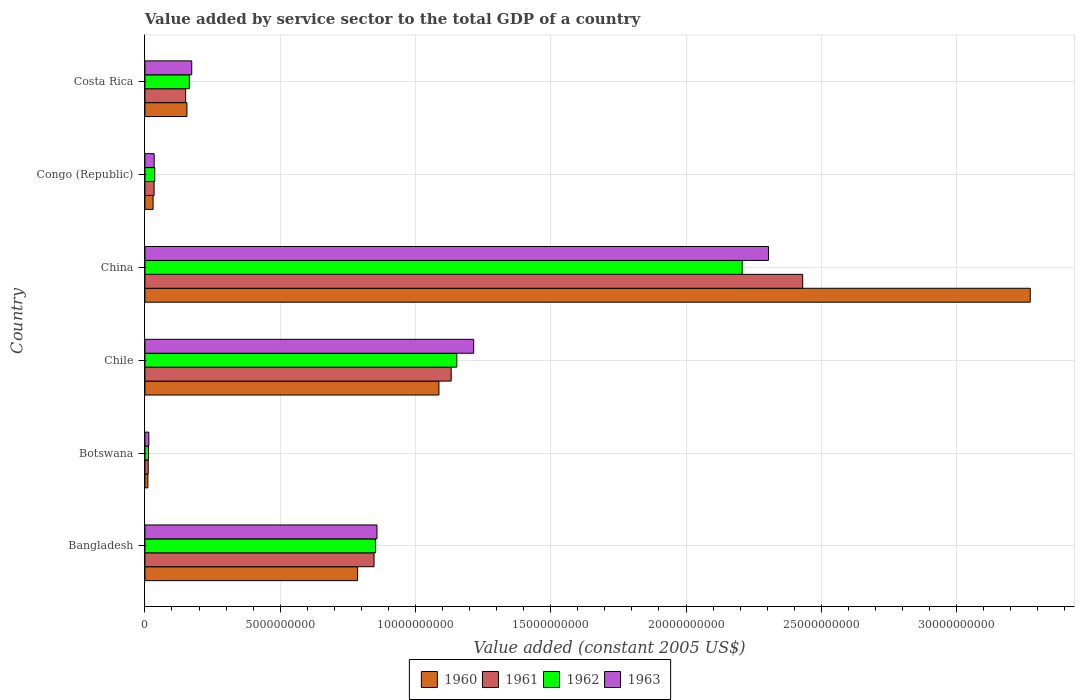How many groups of bars are there?
Provide a succinct answer. 6. Are the number of bars per tick equal to the number of legend labels?
Your response must be concise. Yes. Are the number of bars on each tick of the Y-axis equal?
Ensure brevity in your answer.  Yes. How many bars are there on the 3rd tick from the top?
Your answer should be compact. 4. What is the label of the 4th group of bars from the top?
Your answer should be compact. Chile. What is the value added by service sector in 1962 in Costa Rica?
Offer a very short reply. 1.64e+09. Across all countries, what is the maximum value added by service sector in 1960?
Keep it short and to the point. 3.27e+1. Across all countries, what is the minimum value added by service sector in 1961?
Offer a very short reply. 1.22e+08. In which country was the value added by service sector in 1960 maximum?
Your answer should be very brief. China. In which country was the value added by service sector in 1963 minimum?
Provide a short and direct response. Botswana. What is the total value added by service sector in 1960 in the graph?
Keep it short and to the point. 5.34e+1. What is the difference between the value added by service sector in 1962 in Bangladesh and that in Botswana?
Ensure brevity in your answer.  8.39e+09. What is the difference between the value added by service sector in 1962 in Botswana and the value added by service sector in 1963 in Bangladesh?
Keep it short and to the point. -8.44e+09. What is the average value added by service sector in 1960 per country?
Offer a terse response. 8.90e+09. What is the difference between the value added by service sector in 1962 and value added by service sector in 1961 in China?
Ensure brevity in your answer.  -2.24e+09. What is the ratio of the value added by service sector in 1963 in Congo (Republic) to that in Costa Rica?
Offer a terse response. 0.2. Is the difference between the value added by service sector in 1962 in Bangladesh and Costa Rica greater than the difference between the value added by service sector in 1961 in Bangladesh and Costa Rica?
Keep it short and to the point. No. What is the difference between the highest and the second highest value added by service sector in 1962?
Provide a short and direct response. 1.05e+1. What is the difference between the highest and the lowest value added by service sector in 1960?
Your answer should be compact. 3.26e+1. In how many countries, is the value added by service sector in 1960 greater than the average value added by service sector in 1960 taken over all countries?
Provide a short and direct response. 2. Is the sum of the value added by service sector in 1963 in Bangladesh and Chile greater than the maximum value added by service sector in 1960 across all countries?
Your answer should be compact. No. Is it the case that in every country, the sum of the value added by service sector in 1961 and value added by service sector in 1962 is greater than the sum of value added by service sector in 1963 and value added by service sector in 1960?
Your answer should be very brief. No. What does the 3rd bar from the bottom in Congo (Republic) represents?
Offer a terse response. 1962. How many bars are there?
Make the answer very short. 24. How many countries are there in the graph?
Your answer should be very brief. 6. Does the graph contain any zero values?
Your response must be concise. No. Does the graph contain grids?
Ensure brevity in your answer.  Yes. How many legend labels are there?
Your answer should be very brief. 4. How are the legend labels stacked?
Offer a very short reply. Horizontal. What is the title of the graph?
Offer a terse response. Value added by service sector to the total GDP of a country. What is the label or title of the X-axis?
Offer a very short reply. Value added (constant 2005 US$). What is the label or title of the Y-axis?
Keep it short and to the point. Country. What is the Value added (constant 2005 US$) in 1960 in Bangladesh?
Your response must be concise. 7.86e+09. What is the Value added (constant 2005 US$) in 1961 in Bangladesh?
Your answer should be compact. 8.47e+09. What is the Value added (constant 2005 US$) of 1962 in Bangladesh?
Keep it short and to the point. 8.52e+09. What is the Value added (constant 2005 US$) in 1963 in Bangladesh?
Keep it short and to the point. 8.58e+09. What is the Value added (constant 2005 US$) in 1960 in Botswana?
Your answer should be very brief. 1.11e+08. What is the Value added (constant 2005 US$) in 1961 in Botswana?
Offer a terse response. 1.22e+08. What is the Value added (constant 2005 US$) in 1962 in Botswana?
Your answer should be very brief. 1.32e+08. What is the Value added (constant 2005 US$) of 1963 in Botswana?
Your answer should be very brief. 1.45e+08. What is the Value added (constant 2005 US$) of 1960 in Chile?
Give a very brief answer. 1.09e+1. What is the Value added (constant 2005 US$) of 1961 in Chile?
Your response must be concise. 1.13e+1. What is the Value added (constant 2005 US$) of 1962 in Chile?
Give a very brief answer. 1.15e+1. What is the Value added (constant 2005 US$) of 1963 in Chile?
Your answer should be very brief. 1.22e+1. What is the Value added (constant 2005 US$) of 1960 in China?
Keep it short and to the point. 3.27e+1. What is the Value added (constant 2005 US$) in 1961 in China?
Your answer should be compact. 2.43e+1. What is the Value added (constant 2005 US$) of 1962 in China?
Make the answer very short. 2.21e+1. What is the Value added (constant 2005 US$) of 1963 in China?
Make the answer very short. 2.30e+1. What is the Value added (constant 2005 US$) in 1960 in Congo (Republic)?
Your answer should be compact. 3.02e+08. What is the Value added (constant 2005 US$) of 1961 in Congo (Republic)?
Your answer should be compact. 3.39e+08. What is the Value added (constant 2005 US$) of 1962 in Congo (Republic)?
Provide a short and direct response. 3.64e+08. What is the Value added (constant 2005 US$) in 1963 in Congo (Republic)?
Your response must be concise. 3.42e+08. What is the Value added (constant 2005 US$) in 1960 in Costa Rica?
Your response must be concise. 1.55e+09. What is the Value added (constant 2005 US$) in 1961 in Costa Rica?
Offer a very short reply. 1.51e+09. What is the Value added (constant 2005 US$) in 1962 in Costa Rica?
Offer a terse response. 1.64e+09. What is the Value added (constant 2005 US$) in 1963 in Costa Rica?
Offer a terse response. 1.73e+09. Across all countries, what is the maximum Value added (constant 2005 US$) of 1960?
Ensure brevity in your answer.  3.27e+1. Across all countries, what is the maximum Value added (constant 2005 US$) in 1961?
Your response must be concise. 2.43e+1. Across all countries, what is the maximum Value added (constant 2005 US$) in 1962?
Keep it short and to the point. 2.21e+1. Across all countries, what is the maximum Value added (constant 2005 US$) in 1963?
Give a very brief answer. 2.30e+1. Across all countries, what is the minimum Value added (constant 2005 US$) of 1960?
Your answer should be compact. 1.11e+08. Across all countries, what is the minimum Value added (constant 2005 US$) in 1961?
Keep it short and to the point. 1.22e+08. Across all countries, what is the minimum Value added (constant 2005 US$) of 1962?
Provide a short and direct response. 1.32e+08. Across all countries, what is the minimum Value added (constant 2005 US$) of 1963?
Ensure brevity in your answer.  1.45e+08. What is the total Value added (constant 2005 US$) in 1960 in the graph?
Keep it short and to the point. 5.34e+1. What is the total Value added (constant 2005 US$) of 1961 in the graph?
Give a very brief answer. 4.61e+1. What is the total Value added (constant 2005 US$) of 1962 in the graph?
Give a very brief answer. 4.43e+1. What is the total Value added (constant 2005 US$) of 1963 in the graph?
Provide a short and direct response. 4.60e+1. What is the difference between the Value added (constant 2005 US$) of 1960 in Bangladesh and that in Botswana?
Keep it short and to the point. 7.75e+09. What is the difference between the Value added (constant 2005 US$) of 1961 in Bangladesh and that in Botswana?
Your answer should be very brief. 8.35e+09. What is the difference between the Value added (constant 2005 US$) of 1962 in Bangladesh and that in Botswana?
Provide a short and direct response. 8.39e+09. What is the difference between the Value added (constant 2005 US$) in 1963 in Bangladesh and that in Botswana?
Ensure brevity in your answer.  8.43e+09. What is the difference between the Value added (constant 2005 US$) of 1960 in Bangladesh and that in Chile?
Your answer should be very brief. -3.01e+09. What is the difference between the Value added (constant 2005 US$) in 1961 in Bangladesh and that in Chile?
Your answer should be very brief. -2.85e+09. What is the difference between the Value added (constant 2005 US$) in 1962 in Bangladesh and that in Chile?
Give a very brief answer. -3.00e+09. What is the difference between the Value added (constant 2005 US$) of 1963 in Bangladesh and that in Chile?
Ensure brevity in your answer.  -3.58e+09. What is the difference between the Value added (constant 2005 US$) of 1960 in Bangladesh and that in China?
Keep it short and to the point. -2.49e+1. What is the difference between the Value added (constant 2005 US$) in 1961 in Bangladesh and that in China?
Your answer should be compact. -1.58e+1. What is the difference between the Value added (constant 2005 US$) in 1962 in Bangladesh and that in China?
Your response must be concise. -1.36e+1. What is the difference between the Value added (constant 2005 US$) of 1963 in Bangladesh and that in China?
Offer a terse response. -1.45e+1. What is the difference between the Value added (constant 2005 US$) of 1960 in Bangladesh and that in Congo (Republic)?
Make the answer very short. 7.56e+09. What is the difference between the Value added (constant 2005 US$) of 1961 in Bangladesh and that in Congo (Republic)?
Keep it short and to the point. 8.13e+09. What is the difference between the Value added (constant 2005 US$) in 1962 in Bangladesh and that in Congo (Republic)?
Give a very brief answer. 8.16e+09. What is the difference between the Value added (constant 2005 US$) in 1963 in Bangladesh and that in Congo (Republic)?
Provide a succinct answer. 8.24e+09. What is the difference between the Value added (constant 2005 US$) of 1960 in Bangladesh and that in Costa Rica?
Offer a very short reply. 6.31e+09. What is the difference between the Value added (constant 2005 US$) in 1961 in Bangladesh and that in Costa Rica?
Your answer should be compact. 6.96e+09. What is the difference between the Value added (constant 2005 US$) in 1962 in Bangladesh and that in Costa Rica?
Your response must be concise. 6.88e+09. What is the difference between the Value added (constant 2005 US$) in 1963 in Bangladesh and that in Costa Rica?
Ensure brevity in your answer.  6.85e+09. What is the difference between the Value added (constant 2005 US$) in 1960 in Botswana and that in Chile?
Provide a succinct answer. -1.08e+1. What is the difference between the Value added (constant 2005 US$) of 1961 in Botswana and that in Chile?
Offer a very short reply. -1.12e+1. What is the difference between the Value added (constant 2005 US$) of 1962 in Botswana and that in Chile?
Keep it short and to the point. -1.14e+1. What is the difference between the Value added (constant 2005 US$) in 1963 in Botswana and that in Chile?
Provide a succinct answer. -1.20e+1. What is the difference between the Value added (constant 2005 US$) of 1960 in Botswana and that in China?
Provide a short and direct response. -3.26e+1. What is the difference between the Value added (constant 2005 US$) in 1961 in Botswana and that in China?
Your answer should be very brief. -2.42e+1. What is the difference between the Value added (constant 2005 US$) of 1962 in Botswana and that in China?
Your response must be concise. -2.19e+1. What is the difference between the Value added (constant 2005 US$) in 1963 in Botswana and that in China?
Ensure brevity in your answer.  -2.29e+1. What is the difference between the Value added (constant 2005 US$) of 1960 in Botswana and that in Congo (Republic)?
Your answer should be compact. -1.91e+08. What is the difference between the Value added (constant 2005 US$) in 1961 in Botswana and that in Congo (Republic)?
Provide a short and direct response. -2.17e+08. What is the difference between the Value added (constant 2005 US$) in 1962 in Botswana and that in Congo (Republic)?
Your answer should be very brief. -2.32e+08. What is the difference between the Value added (constant 2005 US$) in 1963 in Botswana and that in Congo (Republic)?
Ensure brevity in your answer.  -1.97e+08. What is the difference between the Value added (constant 2005 US$) of 1960 in Botswana and that in Costa Rica?
Offer a very short reply. -1.44e+09. What is the difference between the Value added (constant 2005 US$) in 1961 in Botswana and that in Costa Rica?
Give a very brief answer. -1.38e+09. What is the difference between the Value added (constant 2005 US$) of 1962 in Botswana and that in Costa Rica?
Your response must be concise. -1.51e+09. What is the difference between the Value added (constant 2005 US$) of 1963 in Botswana and that in Costa Rica?
Offer a terse response. -1.59e+09. What is the difference between the Value added (constant 2005 US$) of 1960 in Chile and that in China?
Your answer should be very brief. -2.19e+1. What is the difference between the Value added (constant 2005 US$) in 1961 in Chile and that in China?
Provide a succinct answer. -1.30e+1. What is the difference between the Value added (constant 2005 US$) in 1962 in Chile and that in China?
Your answer should be very brief. -1.05e+1. What is the difference between the Value added (constant 2005 US$) in 1963 in Chile and that in China?
Give a very brief answer. -1.09e+1. What is the difference between the Value added (constant 2005 US$) in 1960 in Chile and that in Congo (Republic)?
Your answer should be compact. 1.06e+1. What is the difference between the Value added (constant 2005 US$) in 1961 in Chile and that in Congo (Republic)?
Your answer should be very brief. 1.10e+1. What is the difference between the Value added (constant 2005 US$) of 1962 in Chile and that in Congo (Republic)?
Make the answer very short. 1.12e+1. What is the difference between the Value added (constant 2005 US$) in 1963 in Chile and that in Congo (Republic)?
Provide a succinct answer. 1.18e+1. What is the difference between the Value added (constant 2005 US$) in 1960 in Chile and that in Costa Rica?
Offer a very short reply. 9.31e+09. What is the difference between the Value added (constant 2005 US$) of 1961 in Chile and that in Costa Rica?
Your answer should be compact. 9.81e+09. What is the difference between the Value added (constant 2005 US$) of 1962 in Chile and that in Costa Rica?
Keep it short and to the point. 9.89e+09. What is the difference between the Value added (constant 2005 US$) of 1963 in Chile and that in Costa Rica?
Provide a short and direct response. 1.04e+1. What is the difference between the Value added (constant 2005 US$) of 1960 in China and that in Congo (Republic)?
Make the answer very short. 3.24e+1. What is the difference between the Value added (constant 2005 US$) of 1961 in China and that in Congo (Republic)?
Your answer should be compact. 2.40e+1. What is the difference between the Value added (constant 2005 US$) in 1962 in China and that in Congo (Republic)?
Give a very brief answer. 2.17e+1. What is the difference between the Value added (constant 2005 US$) in 1963 in China and that in Congo (Republic)?
Offer a terse response. 2.27e+1. What is the difference between the Value added (constant 2005 US$) of 1960 in China and that in Costa Rica?
Make the answer very short. 3.12e+1. What is the difference between the Value added (constant 2005 US$) in 1961 in China and that in Costa Rica?
Your answer should be compact. 2.28e+1. What is the difference between the Value added (constant 2005 US$) in 1962 in China and that in Costa Rica?
Provide a short and direct response. 2.04e+1. What is the difference between the Value added (constant 2005 US$) of 1963 in China and that in Costa Rica?
Offer a terse response. 2.13e+1. What is the difference between the Value added (constant 2005 US$) in 1960 in Congo (Republic) and that in Costa Rica?
Provide a short and direct response. -1.25e+09. What is the difference between the Value added (constant 2005 US$) of 1961 in Congo (Republic) and that in Costa Rica?
Your answer should be very brief. -1.17e+09. What is the difference between the Value added (constant 2005 US$) in 1962 in Congo (Republic) and that in Costa Rica?
Ensure brevity in your answer.  -1.28e+09. What is the difference between the Value added (constant 2005 US$) in 1963 in Congo (Republic) and that in Costa Rica?
Ensure brevity in your answer.  -1.39e+09. What is the difference between the Value added (constant 2005 US$) of 1960 in Bangladesh and the Value added (constant 2005 US$) of 1961 in Botswana?
Make the answer very short. 7.74e+09. What is the difference between the Value added (constant 2005 US$) of 1960 in Bangladesh and the Value added (constant 2005 US$) of 1962 in Botswana?
Your response must be concise. 7.73e+09. What is the difference between the Value added (constant 2005 US$) in 1960 in Bangladesh and the Value added (constant 2005 US$) in 1963 in Botswana?
Keep it short and to the point. 7.72e+09. What is the difference between the Value added (constant 2005 US$) of 1961 in Bangladesh and the Value added (constant 2005 US$) of 1962 in Botswana?
Give a very brief answer. 8.34e+09. What is the difference between the Value added (constant 2005 US$) in 1961 in Bangladesh and the Value added (constant 2005 US$) in 1963 in Botswana?
Your response must be concise. 8.32e+09. What is the difference between the Value added (constant 2005 US$) in 1962 in Bangladesh and the Value added (constant 2005 US$) in 1963 in Botswana?
Offer a terse response. 8.38e+09. What is the difference between the Value added (constant 2005 US$) in 1960 in Bangladesh and the Value added (constant 2005 US$) in 1961 in Chile?
Your answer should be very brief. -3.46e+09. What is the difference between the Value added (constant 2005 US$) in 1960 in Bangladesh and the Value added (constant 2005 US$) in 1962 in Chile?
Provide a succinct answer. -3.67e+09. What is the difference between the Value added (constant 2005 US$) in 1960 in Bangladesh and the Value added (constant 2005 US$) in 1963 in Chile?
Provide a succinct answer. -4.29e+09. What is the difference between the Value added (constant 2005 US$) of 1961 in Bangladesh and the Value added (constant 2005 US$) of 1962 in Chile?
Offer a very short reply. -3.06e+09. What is the difference between the Value added (constant 2005 US$) in 1961 in Bangladesh and the Value added (constant 2005 US$) in 1963 in Chile?
Your answer should be compact. -3.68e+09. What is the difference between the Value added (constant 2005 US$) of 1962 in Bangladesh and the Value added (constant 2005 US$) of 1963 in Chile?
Provide a short and direct response. -3.63e+09. What is the difference between the Value added (constant 2005 US$) of 1960 in Bangladesh and the Value added (constant 2005 US$) of 1961 in China?
Your answer should be compact. -1.65e+1. What is the difference between the Value added (constant 2005 US$) in 1960 in Bangladesh and the Value added (constant 2005 US$) in 1962 in China?
Your answer should be very brief. -1.42e+1. What is the difference between the Value added (constant 2005 US$) of 1960 in Bangladesh and the Value added (constant 2005 US$) of 1963 in China?
Make the answer very short. -1.52e+1. What is the difference between the Value added (constant 2005 US$) in 1961 in Bangladesh and the Value added (constant 2005 US$) in 1962 in China?
Keep it short and to the point. -1.36e+1. What is the difference between the Value added (constant 2005 US$) of 1961 in Bangladesh and the Value added (constant 2005 US$) of 1963 in China?
Your response must be concise. -1.46e+1. What is the difference between the Value added (constant 2005 US$) of 1962 in Bangladesh and the Value added (constant 2005 US$) of 1963 in China?
Offer a terse response. -1.45e+1. What is the difference between the Value added (constant 2005 US$) in 1960 in Bangladesh and the Value added (constant 2005 US$) in 1961 in Congo (Republic)?
Keep it short and to the point. 7.52e+09. What is the difference between the Value added (constant 2005 US$) of 1960 in Bangladesh and the Value added (constant 2005 US$) of 1962 in Congo (Republic)?
Keep it short and to the point. 7.50e+09. What is the difference between the Value added (constant 2005 US$) in 1960 in Bangladesh and the Value added (constant 2005 US$) in 1963 in Congo (Republic)?
Provide a short and direct response. 7.52e+09. What is the difference between the Value added (constant 2005 US$) in 1961 in Bangladesh and the Value added (constant 2005 US$) in 1962 in Congo (Republic)?
Offer a very short reply. 8.11e+09. What is the difference between the Value added (constant 2005 US$) of 1961 in Bangladesh and the Value added (constant 2005 US$) of 1963 in Congo (Republic)?
Give a very brief answer. 8.13e+09. What is the difference between the Value added (constant 2005 US$) in 1962 in Bangladesh and the Value added (constant 2005 US$) in 1963 in Congo (Republic)?
Offer a terse response. 8.18e+09. What is the difference between the Value added (constant 2005 US$) in 1960 in Bangladesh and the Value added (constant 2005 US$) in 1961 in Costa Rica?
Provide a succinct answer. 6.36e+09. What is the difference between the Value added (constant 2005 US$) of 1960 in Bangladesh and the Value added (constant 2005 US$) of 1962 in Costa Rica?
Your response must be concise. 6.22e+09. What is the difference between the Value added (constant 2005 US$) of 1960 in Bangladesh and the Value added (constant 2005 US$) of 1963 in Costa Rica?
Give a very brief answer. 6.13e+09. What is the difference between the Value added (constant 2005 US$) in 1961 in Bangladesh and the Value added (constant 2005 US$) in 1962 in Costa Rica?
Keep it short and to the point. 6.83e+09. What is the difference between the Value added (constant 2005 US$) in 1961 in Bangladesh and the Value added (constant 2005 US$) in 1963 in Costa Rica?
Make the answer very short. 6.74e+09. What is the difference between the Value added (constant 2005 US$) of 1962 in Bangladesh and the Value added (constant 2005 US$) of 1963 in Costa Rica?
Provide a succinct answer. 6.79e+09. What is the difference between the Value added (constant 2005 US$) of 1960 in Botswana and the Value added (constant 2005 US$) of 1961 in Chile?
Give a very brief answer. -1.12e+1. What is the difference between the Value added (constant 2005 US$) of 1960 in Botswana and the Value added (constant 2005 US$) of 1962 in Chile?
Provide a succinct answer. -1.14e+1. What is the difference between the Value added (constant 2005 US$) in 1960 in Botswana and the Value added (constant 2005 US$) in 1963 in Chile?
Your answer should be very brief. -1.20e+1. What is the difference between the Value added (constant 2005 US$) in 1961 in Botswana and the Value added (constant 2005 US$) in 1962 in Chile?
Give a very brief answer. -1.14e+1. What is the difference between the Value added (constant 2005 US$) of 1961 in Botswana and the Value added (constant 2005 US$) of 1963 in Chile?
Your response must be concise. -1.20e+1. What is the difference between the Value added (constant 2005 US$) of 1962 in Botswana and the Value added (constant 2005 US$) of 1963 in Chile?
Give a very brief answer. -1.20e+1. What is the difference between the Value added (constant 2005 US$) in 1960 in Botswana and the Value added (constant 2005 US$) in 1961 in China?
Give a very brief answer. -2.42e+1. What is the difference between the Value added (constant 2005 US$) in 1960 in Botswana and the Value added (constant 2005 US$) in 1962 in China?
Provide a succinct answer. -2.20e+1. What is the difference between the Value added (constant 2005 US$) of 1960 in Botswana and the Value added (constant 2005 US$) of 1963 in China?
Provide a succinct answer. -2.29e+1. What is the difference between the Value added (constant 2005 US$) of 1961 in Botswana and the Value added (constant 2005 US$) of 1962 in China?
Ensure brevity in your answer.  -2.20e+1. What is the difference between the Value added (constant 2005 US$) of 1961 in Botswana and the Value added (constant 2005 US$) of 1963 in China?
Offer a terse response. -2.29e+1. What is the difference between the Value added (constant 2005 US$) of 1962 in Botswana and the Value added (constant 2005 US$) of 1963 in China?
Provide a succinct answer. -2.29e+1. What is the difference between the Value added (constant 2005 US$) in 1960 in Botswana and the Value added (constant 2005 US$) in 1961 in Congo (Republic)?
Make the answer very short. -2.28e+08. What is the difference between the Value added (constant 2005 US$) in 1960 in Botswana and the Value added (constant 2005 US$) in 1962 in Congo (Republic)?
Your response must be concise. -2.53e+08. What is the difference between the Value added (constant 2005 US$) in 1960 in Botswana and the Value added (constant 2005 US$) in 1963 in Congo (Republic)?
Your response must be concise. -2.31e+08. What is the difference between the Value added (constant 2005 US$) of 1961 in Botswana and the Value added (constant 2005 US$) of 1962 in Congo (Republic)?
Give a very brief answer. -2.42e+08. What is the difference between the Value added (constant 2005 US$) of 1961 in Botswana and the Value added (constant 2005 US$) of 1963 in Congo (Republic)?
Provide a short and direct response. -2.20e+08. What is the difference between the Value added (constant 2005 US$) in 1962 in Botswana and the Value added (constant 2005 US$) in 1963 in Congo (Republic)?
Your answer should be compact. -2.10e+08. What is the difference between the Value added (constant 2005 US$) in 1960 in Botswana and the Value added (constant 2005 US$) in 1961 in Costa Rica?
Give a very brief answer. -1.39e+09. What is the difference between the Value added (constant 2005 US$) of 1960 in Botswana and the Value added (constant 2005 US$) of 1962 in Costa Rica?
Your response must be concise. -1.53e+09. What is the difference between the Value added (constant 2005 US$) in 1960 in Botswana and the Value added (constant 2005 US$) in 1963 in Costa Rica?
Provide a short and direct response. -1.62e+09. What is the difference between the Value added (constant 2005 US$) in 1961 in Botswana and the Value added (constant 2005 US$) in 1962 in Costa Rica?
Your response must be concise. -1.52e+09. What is the difference between the Value added (constant 2005 US$) in 1961 in Botswana and the Value added (constant 2005 US$) in 1963 in Costa Rica?
Keep it short and to the point. -1.61e+09. What is the difference between the Value added (constant 2005 US$) in 1962 in Botswana and the Value added (constant 2005 US$) in 1963 in Costa Rica?
Provide a succinct answer. -1.60e+09. What is the difference between the Value added (constant 2005 US$) in 1960 in Chile and the Value added (constant 2005 US$) in 1961 in China?
Ensure brevity in your answer.  -1.34e+1. What is the difference between the Value added (constant 2005 US$) in 1960 in Chile and the Value added (constant 2005 US$) in 1962 in China?
Offer a very short reply. -1.12e+1. What is the difference between the Value added (constant 2005 US$) of 1960 in Chile and the Value added (constant 2005 US$) of 1963 in China?
Offer a very short reply. -1.22e+1. What is the difference between the Value added (constant 2005 US$) in 1961 in Chile and the Value added (constant 2005 US$) in 1962 in China?
Your response must be concise. -1.08e+1. What is the difference between the Value added (constant 2005 US$) of 1961 in Chile and the Value added (constant 2005 US$) of 1963 in China?
Provide a succinct answer. -1.17e+1. What is the difference between the Value added (constant 2005 US$) in 1962 in Chile and the Value added (constant 2005 US$) in 1963 in China?
Give a very brief answer. -1.15e+1. What is the difference between the Value added (constant 2005 US$) of 1960 in Chile and the Value added (constant 2005 US$) of 1961 in Congo (Republic)?
Ensure brevity in your answer.  1.05e+1. What is the difference between the Value added (constant 2005 US$) of 1960 in Chile and the Value added (constant 2005 US$) of 1962 in Congo (Republic)?
Your answer should be compact. 1.05e+1. What is the difference between the Value added (constant 2005 US$) of 1960 in Chile and the Value added (constant 2005 US$) of 1963 in Congo (Republic)?
Ensure brevity in your answer.  1.05e+1. What is the difference between the Value added (constant 2005 US$) of 1961 in Chile and the Value added (constant 2005 US$) of 1962 in Congo (Republic)?
Your answer should be compact. 1.10e+1. What is the difference between the Value added (constant 2005 US$) in 1961 in Chile and the Value added (constant 2005 US$) in 1963 in Congo (Republic)?
Your answer should be compact. 1.10e+1. What is the difference between the Value added (constant 2005 US$) in 1962 in Chile and the Value added (constant 2005 US$) in 1963 in Congo (Republic)?
Provide a short and direct response. 1.12e+1. What is the difference between the Value added (constant 2005 US$) in 1960 in Chile and the Value added (constant 2005 US$) in 1961 in Costa Rica?
Keep it short and to the point. 9.36e+09. What is the difference between the Value added (constant 2005 US$) in 1960 in Chile and the Value added (constant 2005 US$) in 1962 in Costa Rica?
Give a very brief answer. 9.23e+09. What is the difference between the Value added (constant 2005 US$) of 1960 in Chile and the Value added (constant 2005 US$) of 1963 in Costa Rica?
Keep it short and to the point. 9.14e+09. What is the difference between the Value added (constant 2005 US$) of 1961 in Chile and the Value added (constant 2005 US$) of 1962 in Costa Rica?
Your answer should be very brief. 9.68e+09. What is the difference between the Value added (constant 2005 US$) of 1961 in Chile and the Value added (constant 2005 US$) of 1963 in Costa Rica?
Your answer should be very brief. 9.59e+09. What is the difference between the Value added (constant 2005 US$) in 1962 in Chile and the Value added (constant 2005 US$) in 1963 in Costa Rica?
Provide a succinct answer. 9.80e+09. What is the difference between the Value added (constant 2005 US$) of 1960 in China and the Value added (constant 2005 US$) of 1961 in Congo (Republic)?
Give a very brief answer. 3.24e+1. What is the difference between the Value added (constant 2005 US$) in 1960 in China and the Value added (constant 2005 US$) in 1962 in Congo (Republic)?
Make the answer very short. 3.24e+1. What is the difference between the Value added (constant 2005 US$) in 1960 in China and the Value added (constant 2005 US$) in 1963 in Congo (Republic)?
Give a very brief answer. 3.24e+1. What is the difference between the Value added (constant 2005 US$) of 1961 in China and the Value added (constant 2005 US$) of 1962 in Congo (Republic)?
Your response must be concise. 2.39e+1. What is the difference between the Value added (constant 2005 US$) of 1961 in China and the Value added (constant 2005 US$) of 1963 in Congo (Republic)?
Keep it short and to the point. 2.40e+1. What is the difference between the Value added (constant 2005 US$) of 1962 in China and the Value added (constant 2005 US$) of 1963 in Congo (Republic)?
Keep it short and to the point. 2.17e+1. What is the difference between the Value added (constant 2005 US$) of 1960 in China and the Value added (constant 2005 US$) of 1961 in Costa Rica?
Keep it short and to the point. 3.12e+1. What is the difference between the Value added (constant 2005 US$) in 1960 in China and the Value added (constant 2005 US$) in 1962 in Costa Rica?
Give a very brief answer. 3.11e+1. What is the difference between the Value added (constant 2005 US$) in 1960 in China and the Value added (constant 2005 US$) in 1963 in Costa Rica?
Keep it short and to the point. 3.10e+1. What is the difference between the Value added (constant 2005 US$) of 1961 in China and the Value added (constant 2005 US$) of 1962 in Costa Rica?
Give a very brief answer. 2.27e+1. What is the difference between the Value added (constant 2005 US$) in 1961 in China and the Value added (constant 2005 US$) in 1963 in Costa Rica?
Offer a very short reply. 2.26e+1. What is the difference between the Value added (constant 2005 US$) of 1962 in China and the Value added (constant 2005 US$) of 1963 in Costa Rica?
Give a very brief answer. 2.03e+1. What is the difference between the Value added (constant 2005 US$) in 1960 in Congo (Republic) and the Value added (constant 2005 US$) in 1961 in Costa Rica?
Provide a succinct answer. -1.20e+09. What is the difference between the Value added (constant 2005 US$) of 1960 in Congo (Republic) and the Value added (constant 2005 US$) of 1962 in Costa Rica?
Provide a succinct answer. -1.34e+09. What is the difference between the Value added (constant 2005 US$) in 1960 in Congo (Republic) and the Value added (constant 2005 US$) in 1963 in Costa Rica?
Make the answer very short. -1.43e+09. What is the difference between the Value added (constant 2005 US$) of 1961 in Congo (Republic) and the Value added (constant 2005 US$) of 1962 in Costa Rica?
Offer a terse response. -1.30e+09. What is the difference between the Value added (constant 2005 US$) of 1961 in Congo (Republic) and the Value added (constant 2005 US$) of 1963 in Costa Rica?
Make the answer very short. -1.39e+09. What is the difference between the Value added (constant 2005 US$) of 1962 in Congo (Republic) and the Value added (constant 2005 US$) of 1963 in Costa Rica?
Provide a short and direct response. -1.37e+09. What is the average Value added (constant 2005 US$) in 1960 per country?
Offer a very short reply. 8.90e+09. What is the average Value added (constant 2005 US$) of 1961 per country?
Ensure brevity in your answer.  7.68e+09. What is the average Value added (constant 2005 US$) in 1962 per country?
Offer a very short reply. 7.38e+09. What is the average Value added (constant 2005 US$) of 1963 per country?
Provide a succinct answer. 7.67e+09. What is the difference between the Value added (constant 2005 US$) of 1960 and Value added (constant 2005 US$) of 1961 in Bangladesh?
Make the answer very short. -6.09e+08. What is the difference between the Value added (constant 2005 US$) in 1960 and Value added (constant 2005 US$) in 1962 in Bangladesh?
Give a very brief answer. -6.62e+08. What is the difference between the Value added (constant 2005 US$) in 1960 and Value added (constant 2005 US$) in 1963 in Bangladesh?
Provide a succinct answer. -7.16e+08. What is the difference between the Value added (constant 2005 US$) in 1961 and Value added (constant 2005 US$) in 1962 in Bangladesh?
Provide a short and direct response. -5.33e+07. What is the difference between the Value added (constant 2005 US$) in 1961 and Value added (constant 2005 US$) in 1963 in Bangladesh?
Make the answer very short. -1.08e+08. What is the difference between the Value added (constant 2005 US$) in 1962 and Value added (constant 2005 US$) in 1963 in Bangladesh?
Provide a short and direct response. -5.45e+07. What is the difference between the Value added (constant 2005 US$) in 1960 and Value added (constant 2005 US$) in 1961 in Botswana?
Make the answer very short. -1.12e+07. What is the difference between the Value added (constant 2005 US$) of 1960 and Value added (constant 2005 US$) of 1962 in Botswana?
Your response must be concise. -2.17e+07. What is the difference between the Value added (constant 2005 US$) of 1960 and Value added (constant 2005 US$) of 1963 in Botswana?
Your response must be concise. -3.45e+07. What is the difference between the Value added (constant 2005 US$) of 1961 and Value added (constant 2005 US$) of 1962 in Botswana?
Give a very brief answer. -1.05e+07. What is the difference between the Value added (constant 2005 US$) in 1961 and Value added (constant 2005 US$) in 1963 in Botswana?
Your response must be concise. -2.33e+07. What is the difference between the Value added (constant 2005 US$) in 1962 and Value added (constant 2005 US$) in 1963 in Botswana?
Provide a succinct answer. -1.28e+07. What is the difference between the Value added (constant 2005 US$) of 1960 and Value added (constant 2005 US$) of 1961 in Chile?
Your answer should be very brief. -4.53e+08. What is the difference between the Value added (constant 2005 US$) of 1960 and Value added (constant 2005 US$) of 1962 in Chile?
Your response must be concise. -6.60e+08. What is the difference between the Value added (constant 2005 US$) of 1960 and Value added (constant 2005 US$) of 1963 in Chile?
Offer a very short reply. -1.29e+09. What is the difference between the Value added (constant 2005 US$) in 1961 and Value added (constant 2005 US$) in 1962 in Chile?
Offer a terse response. -2.07e+08. What is the difference between the Value added (constant 2005 US$) of 1961 and Value added (constant 2005 US$) of 1963 in Chile?
Give a very brief answer. -8.32e+08. What is the difference between the Value added (constant 2005 US$) in 1962 and Value added (constant 2005 US$) in 1963 in Chile?
Your answer should be very brief. -6.25e+08. What is the difference between the Value added (constant 2005 US$) of 1960 and Value added (constant 2005 US$) of 1961 in China?
Provide a short and direct response. 8.41e+09. What is the difference between the Value added (constant 2005 US$) of 1960 and Value added (constant 2005 US$) of 1962 in China?
Your answer should be compact. 1.06e+1. What is the difference between the Value added (constant 2005 US$) of 1960 and Value added (constant 2005 US$) of 1963 in China?
Offer a very short reply. 9.68e+09. What is the difference between the Value added (constant 2005 US$) of 1961 and Value added (constant 2005 US$) of 1962 in China?
Offer a terse response. 2.24e+09. What is the difference between the Value added (constant 2005 US$) in 1961 and Value added (constant 2005 US$) in 1963 in China?
Provide a succinct answer. 1.27e+09. What is the difference between the Value added (constant 2005 US$) of 1962 and Value added (constant 2005 US$) of 1963 in China?
Your answer should be very brief. -9.71e+08. What is the difference between the Value added (constant 2005 US$) of 1960 and Value added (constant 2005 US$) of 1961 in Congo (Republic)?
Give a very brief answer. -3.74e+07. What is the difference between the Value added (constant 2005 US$) of 1960 and Value added (constant 2005 US$) of 1962 in Congo (Republic)?
Offer a very short reply. -6.23e+07. What is the difference between the Value added (constant 2005 US$) of 1960 and Value added (constant 2005 US$) of 1963 in Congo (Republic)?
Your response must be concise. -4.05e+07. What is the difference between the Value added (constant 2005 US$) of 1961 and Value added (constant 2005 US$) of 1962 in Congo (Republic)?
Provide a short and direct response. -2.49e+07. What is the difference between the Value added (constant 2005 US$) of 1961 and Value added (constant 2005 US$) of 1963 in Congo (Republic)?
Give a very brief answer. -3.09e+06. What is the difference between the Value added (constant 2005 US$) in 1962 and Value added (constant 2005 US$) in 1963 in Congo (Republic)?
Ensure brevity in your answer.  2.18e+07. What is the difference between the Value added (constant 2005 US$) of 1960 and Value added (constant 2005 US$) of 1961 in Costa Rica?
Your response must be concise. 4.72e+07. What is the difference between the Value added (constant 2005 US$) of 1960 and Value added (constant 2005 US$) of 1962 in Costa Rica?
Ensure brevity in your answer.  -8.87e+07. What is the difference between the Value added (constant 2005 US$) in 1960 and Value added (constant 2005 US$) in 1963 in Costa Rica?
Ensure brevity in your answer.  -1.78e+08. What is the difference between the Value added (constant 2005 US$) in 1961 and Value added (constant 2005 US$) in 1962 in Costa Rica?
Ensure brevity in your answer.  -1.36e+08. What is the difference between the Value added (constant 2005 US$) in 1961 and Value added (constant 2005 US$) in 1963 in Costa Rica?
Keep it short and to the point. -2.25e+08. What is the difference between the Value added (constant 2005 US$) in 1962 and Value added (constant 2005 US$) in 1963 in Costa Rica?
Your answer should be compact. -8.94e+07. What is the ratio of the Value added (constant 2005 US$) in 1960 in Bangladesh to that in Botswana?
Provide a short and direct response. 71.09. What is the ratio of the Value added (constant 2005 US$) in 1961 in Bangladesh to that in Botswana?
Keep it short and to the point. 69.55. What is the ratio of the Value added (constant 2005 US$) of 1962 in Bangladesh to that in Botswana?
Offer a very short reply. 64.43. What is the ratio of the Value added (constant 2005 US$) in 1963 in Bangladesh to that in Botswana?
Keep it short and to the point. 59.12. What is the ratio of the Value added (constant 2005 US$) of 1960 in Bangladesh to that in Chile?
Provide a succinct answer. 0.72. What is the ratio of the Value added (constant 2005 US$) in 1961 in Bangladesh to that in Chile?
Your answer should be very brief. 0.75. What is the ratio of the Value added (constant 2005 US$) of 1962 in Bangladesh to that in Chile?
Offer a terse response. 0.74. What is the ratio of the Value added (constant 2005 US$) of 1963 in Bangladesh to that in Chile?
Your answer should be very brief. 0.71. What is the ratio of the Value added (constant 2005 US$) of 1960 in Bangladesh to that in China?
Provide a succinct answer. 0.24. What is the ratio of the Value added (constant 2005 US$) of 1961 in Bangladesh to that in China?
Ensure brevity in your answer.  0.35. What is the ratio of the Value added (constant 2005 US$) in 1962 in Bangladesh to that in China?
Provide a succinct answer. 0.39. What is the ratio of the Value added (constant 2005 US$) in 1963 in Bangladesh to that in China?
Provide a succinct answer. 0.37. What is the ratio of the Value added (constant 2005 US$) in 1960 in Bangladesh to that in Congo (Republic)?
Give a very brief answer. 26.07. What is the ratio of the Value added (constant 2005 US$) in 1961 in Bangladesh to that in Congo (Republic)?
Offer a terse response. 24.99. What is the ratio of the Value added (constant 2005 US$) of 1962 in Bangladesh to that in Congo (Republic)?
Provide a short and direct response. 23.42. What is the ratio of the Value added (constant 2005 US$) of 1963 in Bangladesh to that in Congo (Republic)?
Offer a very short reply. 25.08. What is the ratio of the Value added (constant 2005 US$) of 1960 in Bangladesh to that in Costa Rica?
Ensure brevity in your answer.  5.06. What is the ratio of the Value added (constant 2005 US$) in 1961 in Bangladesh to that in Costa Rica?
Offer a very short reply. 5.63. What is the ratio of the Value added (constant 2005 US$) in 1962 in Bangladesh to that in Costa Rica?
Offer a terse response. 5.19. What is the ratio of the Value added (constant 2005 US$) of 1963 in Bangladesh to that in Costa Rica?
Offer a terse response. 4.96. What is the ratio of the Value added (constant 2005 US$) in 1960 in Botswana to that in Chile?
Provide a short and direct response. 0.01. What is the ratio of the Value added (constant 2005 US$) of 1961 in Botswana to that in Chile?
Offer a terse response. 0.01. What is the ratio of the Value added (constant 2005 US$) of 1962 in Botswana to that in Chile?
Keep it short and to the point. 0.01. What is the ratio of the Value added (constant 2005 US$) of 1963 in Botswana to that in Chile?
Give a very brief answer. 0.01. What is the ratio of the Value added (constant 2005 US$) in 1960 in Botswana to that in China?
Offer a terse response. 0. What is the ratio of the Value added (constant 2005 US$) in 1961 in Botswana to that in China?
Ensure brevity in your answer.  0.01. What is the ratio of the Value added (constant 2005 US$) in 1962 in Botswana to that in China?
Your response must be concise. 0.01. What is the ratio of the Value added (constant 2005 US$) of 1963 in Botswana to that in China?
Provide a succinct answer. 0.01. What is the ratio of the Value added (constant 2005 US$) of 1960 in Botswana to that in Congo (Republic)?
Give a very brief answer. 0.37. What is the ratio of the Value added (constant 2005 US$) of 1961 in Botswana to that in Congo (Republic)?
Your answer should be compact. 0.36. What is the ratio of the Value added (constant 2005 US$) of 1962 in Botswana to that in Congo (Republic)?
Provide a succinct answer. 0.36. What is the ratio of the Value added (constant 2005 US$) in 1963 in Botswana to that in Congo (Republic)?
Ensure brevity in your answer.  0.42. What is the ratio of the Value added (constant 2005 US$) in 1960 in Botswana to that in Costa Rica?
Give a very brief answer. 0.07. What is the ratio of the Value added (constant 2005 US$) in 1961 in Botswana to that in Costa Rica?
Offer a very short reply. 0.08. What is the ratio of the Value added (constant 2005 US$) of 1962 in Botswana to that in Costa Rica?
Provide a succinct answer. 0.08. What is the ratio of the Value added (constant 2005 US$) in 1963 in Botswana to that in Costa Rica?
Keep it short and to the point. 0.08. What is the ratio of the Value added (constant 2005 US$) in 1960 in Chile to that in China?
Provide a succinct answer. 0.33. What is the ratio of the Value added (constant 2005 US$) in 1961 in Chile to that in China?
Your response must be concise. 0.47. What is the ratio of the Value added (constant 2005 US$) in 1962 in Chile to that in China?
Offer a terse response. 0.52. What is the ratio of the Value added (constant 2005 US$) of 1963 in Chile to that in China?
Make the answer very short. 0.53. What is the ratio of the Value added (constant 2005 US$) of 1960 in Chile to that in Congo (Republic)?
Make the answer very short. 36.04. What is the ratio of the Value added (constant 2005 US$) in 1961 in Chile to that in Congo (Republic)?
Provide a succinct answer. 33.4. What is the ratio of the Value added (constant 2005 US$) of 1962 in Chile to that in Congo (Republic)?
Provide a short and direct response. 31.68. What is the ratio of the Value added (constant 2005 US$) in 1963 in Chile to that in Congo (Republic)?
Provide a succinct answer. 35.53. What is the ratio of the Value added (constant 2005 US$) of 1960 in Chile to that in Costa Rica?
Ensure brevity in your answer.  7. What is the ratio of the Value added (constant 2005 US$) of 1961 in Chile to that in Costa Rica?
Give a very brief answer. 7.52. What is the ratio of the Value added (constant 2005 US$) in 1962 in Chile to that in Costa Rica?
Give a very brief answer. 7.02. What is the ratio of the Value added (constant 2005 US$) in 1963 in Chile to that in Costa Rica?
Your answer should be very brief. 7.02. What is the ratio of the Value added (constant 2005 US$) of 1960 in China to that in Congo (Republic)?
Give a very brief answer. 108.51. What is the ratio of the Value added (constant 2005 US$) in 1961 in China to that in Congo (Republic)?
Provide a succinct answer. 71.73. What is the ratio of the Value added (constant 2005 US$) of 1962 in China to that in Congo (Republic)?
Your answer should be very brief. 60.67. What is the ratio of the Value added (constant 2005 US$) of 1963 in China to that in Congo (Republic)?
Keep it short and to the point. 67.39. What is the ratio of the Value added (constant 2005 US$) in 1960 in China to that in Costa Rica?
Make the answer very short. 21.08. What is the ratio of the Value added (constant 2005 US$) in 1961 in China to that in Costa Rica?
Keep it short and to the point. 16.15. What is the ratio of the Value added (constant 2005 US$) of 1962 in China to that in Costa Rica?
Your response must be concise. 13.45. What is the ratio of the Value added (constant 2005 US$) of 1963 in China to that in Costa Rica?
Ensure brevity in your answer.  13.32. What is the ratio of the Value added (constant 2005 US$) in 1960 in Congo (Republic) to that in Costa Rica?
Offer a very short reply. 0.19. What is the ratio of the Value added (constant 2005 US$) of 1961 in Congo (Republic) to that in Costa Rica?
Give a very brief answer. 0.23. What is the ratio of the Value added (constant 2005 US$) of 1962 in Congo (Republic) to that in Costa Rica?
Offer a very short reply. 0.22. What is the ratio of the Value added (constant 2005 US$) of 1963 in Congo (Republic) to that in Costa Rica?
Keep it short and to the point. 0.2. What is the difference between the highest and the second highest Value added (constant 2005 US$) in 1960?
Offer a terse response. 2.19e+1. What is the difference between the highest and the second highest Value added (constant 2005 US$) in 1961?
Your answer should be compact. 1.30e+1. What is the difference between the highest and the second highest Value added (constant 2005 US$) of 1962?
Provide a succinct answer. 1.05e+1. What is the difference between the highest and the second highest Value added (constant 2005 US$) of 1963?
Your answer should be very brief. 1.09e+1. What is the difference between the highest and the lowest Value added (constant 2005 US$) in 1960?
Give a very brief answer. 3.26e+1. What is the difference between the highest and the lowest Value added (constant 2005 US$) in 1961?
Give a very brief answer. 2.42e+1. What is the difference between the highest and the lowest Value added (constant 2005 US$) in 1962?
Offer a very short reply. 2.19e+1. What is the difference between the highest and the lowest Value added (constant 2005 US$) of 1963?
Ensure brevity in your answer.  2.29e+1. 